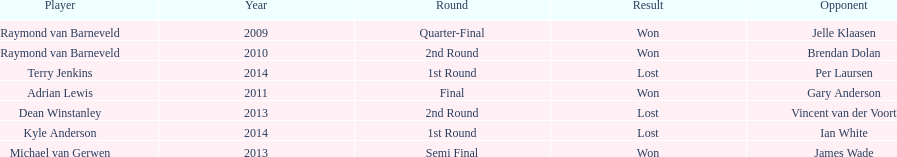Is dean winstanley listed above or below kyle anderson? Above. 